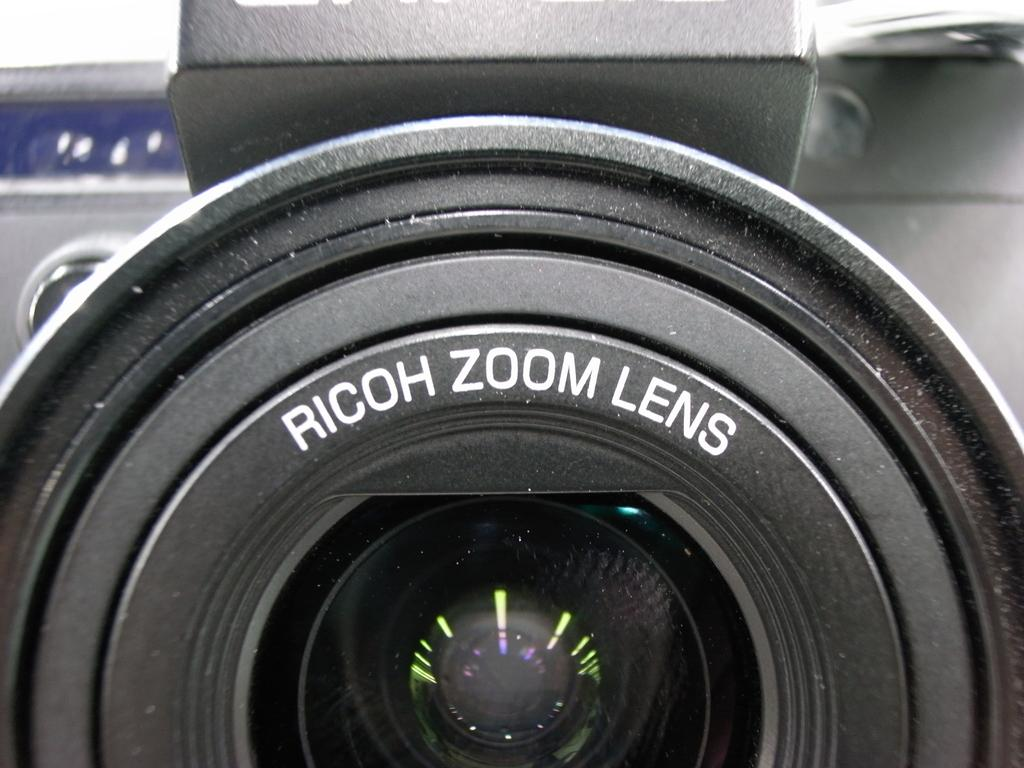What is the main object in the image? The main object in the image is a camera lens. Are there any additional features on the camera lens? Yes, there are letters on the camera lens. What type of bubble can be seen surrounding the camera lens in the image? There is no bubble present around the camera lens in the image. 